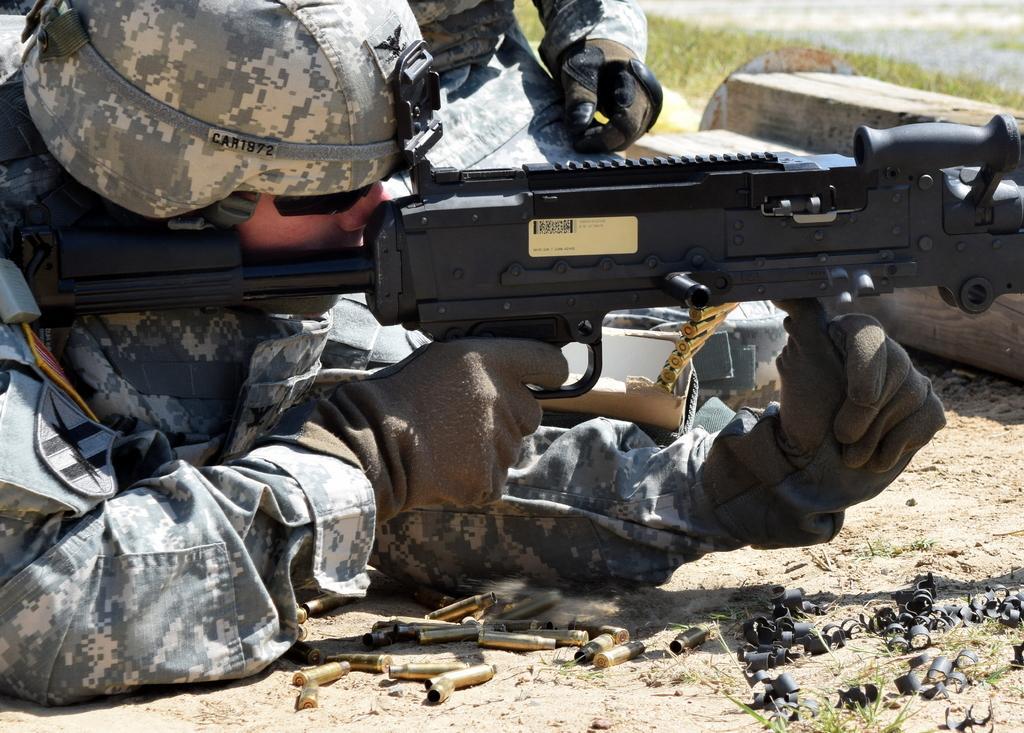Could you give a brief overview of what you see in this image? On the left side, there is a person in gray color dress laying on the ground and holding a black color gun near bullets. These are on the ground. In the background, there is a person kneeling down on the ground near woods and there's grass on the ground. 